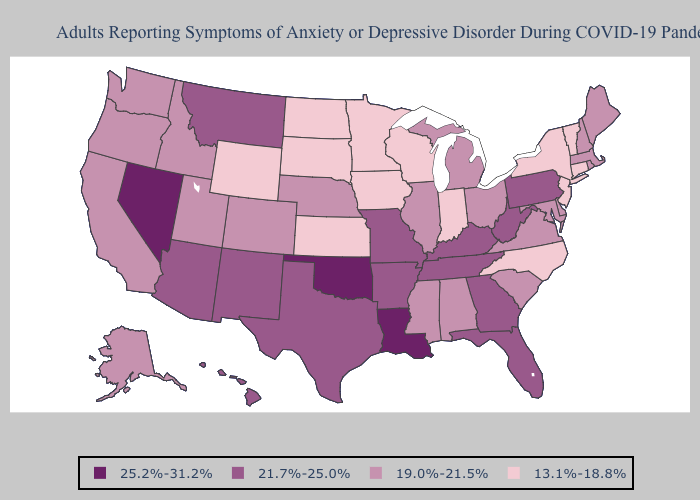What is the lowest value in the USA?
Short answer required. 13.1%-18.8%. Does Louisiana have the highest value in the USA?
Quick response, please. Yes. Which states have the lowest value in the Northeast?
Quick response, please. Connecticut, New Jersey, New York, Vermont. Does Mississippi have the same value as Delaware?
Write a very short answer. Yes. Does California have the lowest value in the West?
Be succinct. No. What is the value of Maine?
Short answer required. 19.0%-21.5%. Name the states that have a value in the range 13.1%-18.8%?
Concise answer only. Connecticut, Indiana, Iowa, Kansas, Minnesota, New Jersey, New York, North Carolina, North Dakota, South Dakota, Vermont, Wisconsin, Wyoming. Name the states that have a value in the range 21.7%-25.0%?
Quick response, please. Arizona, Arkansas, Florida, Georgia, Hawaii, Kentucky, Missouri, Montana, New Mexico, Pennsylvania, Tennessee, Texas, West Virginia. Does Missouri have the highest value in the MidWest?
Short answer required. Yes. Which states have the highest value in the USA?
Give a very brief answer. Louisiana, Nevada, Oklahoma. Name the states that have a value in the range 21.7%-25.0%?
Give a very brief answer. Arizona, Arkansas, Florida, Georgia, Hawaii, Kentucky, Missouri, Montana, New Mexico, Pennsylvania, Tennessee, Texas, West Virginia. What is the value of North Carolina?
Give a very brief answer. 13.1%-18.8%. What is the value of Maine?
Concise answer only. 19.0%-21.5%. Does New York have the lowest value in the Northeast?
Answer briefly. Yes. Does Texas have a lower value than Tennessee?
Be succinct. No. 